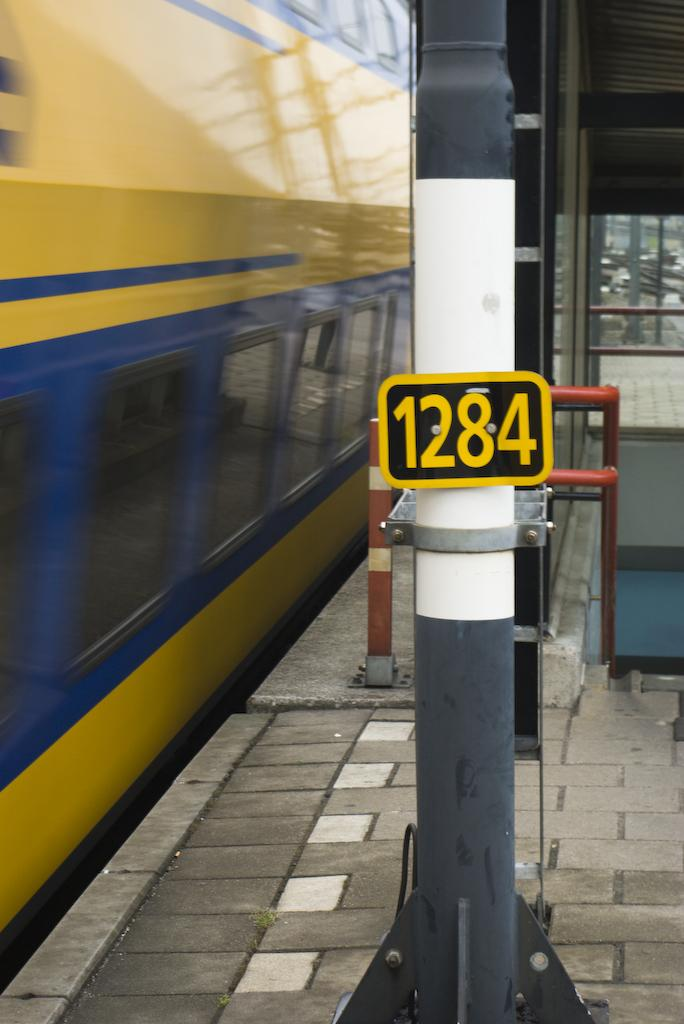<image>
Offer a succinct explanation of the picture presented. a sign that has the numbers 1284 on it 